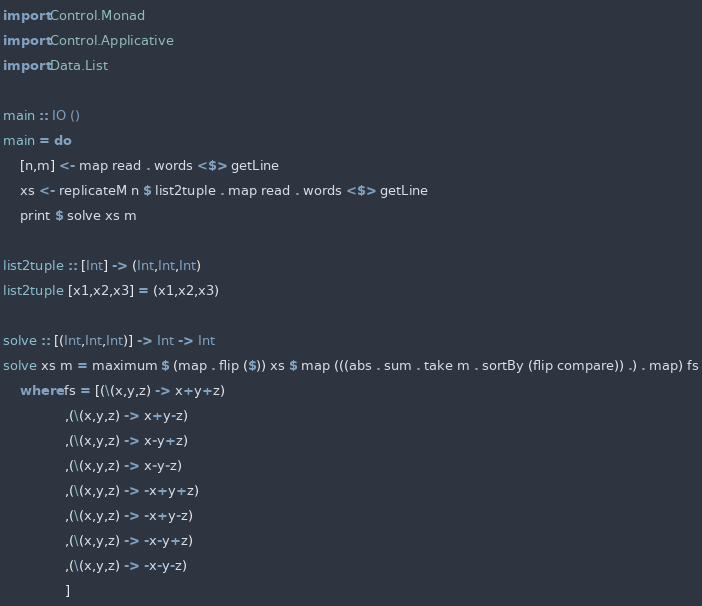Convert code to text. <code><loc_0><loc_0><loc_500><loc_500><_Haskell_>import Control.Monad
import Control.Applicative
import Data.List

main :: IO ()
main = do
    [n,m] <- map read . words <$> getLine
    xs <- replicateM n $ list2tuple . map read . words <$> getLine
    print $ solve xs m

list2tuple :: [Int] -> (Int,Int,Int)
list2tuple [x1,x2,x3] = (x1,x2,x3)

solve :: [(Int,Int,Int)] -> Int -> Int
solve xs m = maximum $ (map . flip ($)) xs $ map (((abs . sum . take m . sortBy (flip compare)) .) . map) fs
    where fs = [(\(x,y,z) -> x+y+z)
               ,(\(x,y,z) -> x+y-z)
               ,(\(x,y,z) -> x-y+z)
               ,(\(x,y,z) -> x-y-z)
               ,(\(x,y,z) -> -x+y+z)
               ,(\(x,y,z) -> -x+y-z)
               ,(\(x,y,z) -> -x-y+z)
               ,(\(x,y,z) -> -x-y-z)
               ]
</code> 